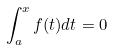Convert formula to latex. <formula><loc_0><loc_0><loc_500><loc_500>\int _ { a } ^ { x } f ( t ) d t = 0</formula> 